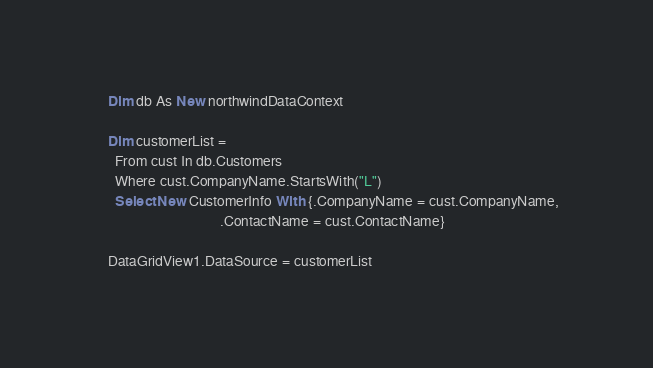Convert code to text. <code><loc_0><loc_0><loc_500><loc_500><_VisualBasic_>    Dim db As New northwindDataContext

    Dim customerList =
      From cust In db.Customers
      Where cust.CompanyName.StartsWith("L")
      Select New CustomerInfo With {.CompanyName = cust.CompanyName,
                                    .ContactName = cust.ContactName}

    DataGridView1.DataSource = customerList</code> 